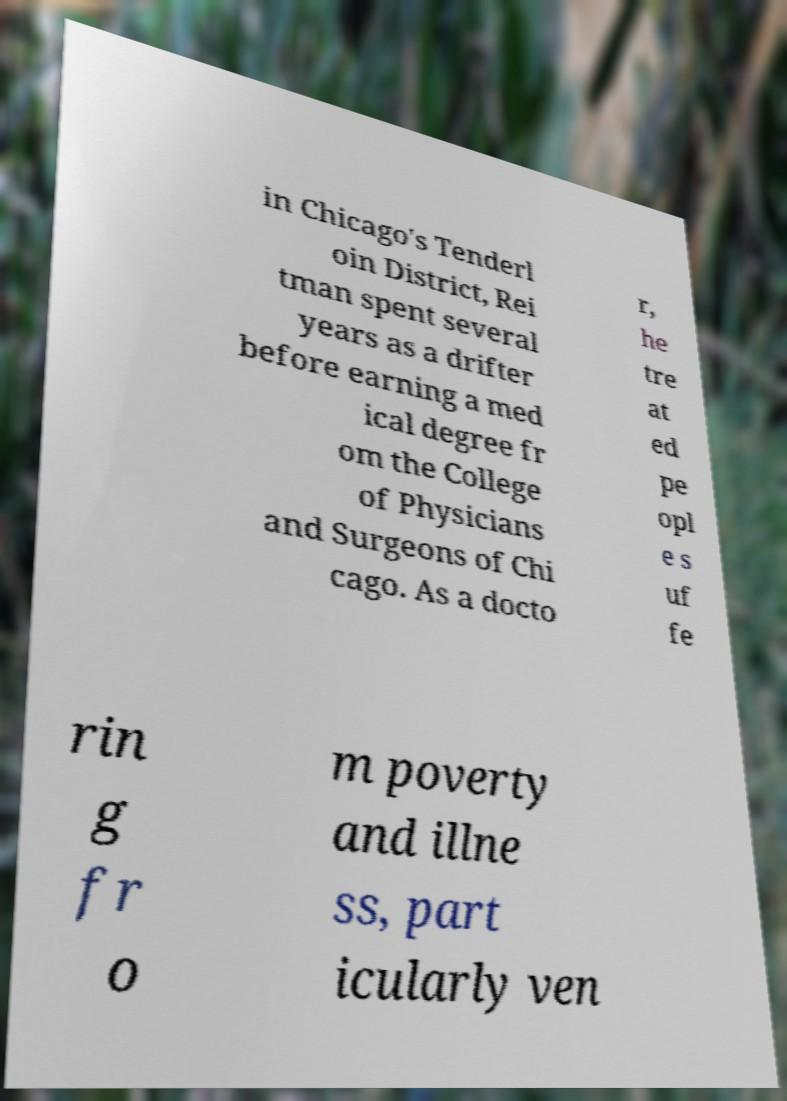Can you accurately transcribe the text from the provided image for me? in Chicago's Tenderl oin District, Rei tman spent several years as a drifter before earning a med ical degree fr om the College of Physicians and Surgeons of Chi cago. As a docto r, he tre at ed pe opl e s uf fe rin g fr o m poverty and illne ss, part icularly ven 